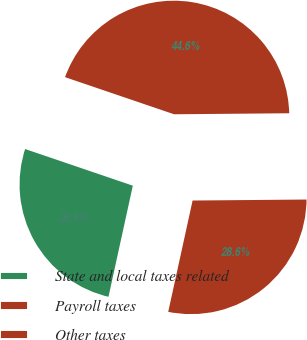<chart> <loc_0><loc_0><loc_500><loc_500><pie_chart><fcel>State and local taxes related<fcel>Payroll taxes<fcel>Other taxes<nl><fcel>26.79%<fcel>28.57%<fcel>44.64%<nl></chart> 